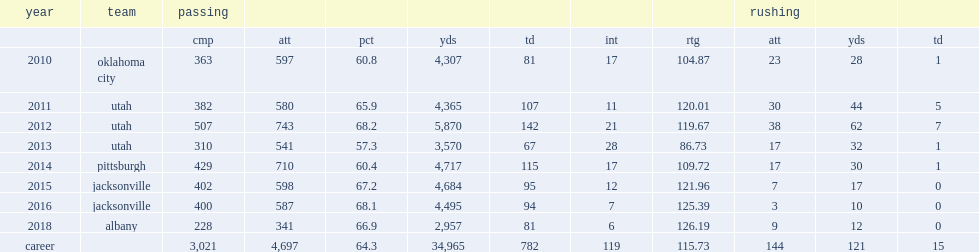How many touchdown passes did grady get in 2012? 142.0. 